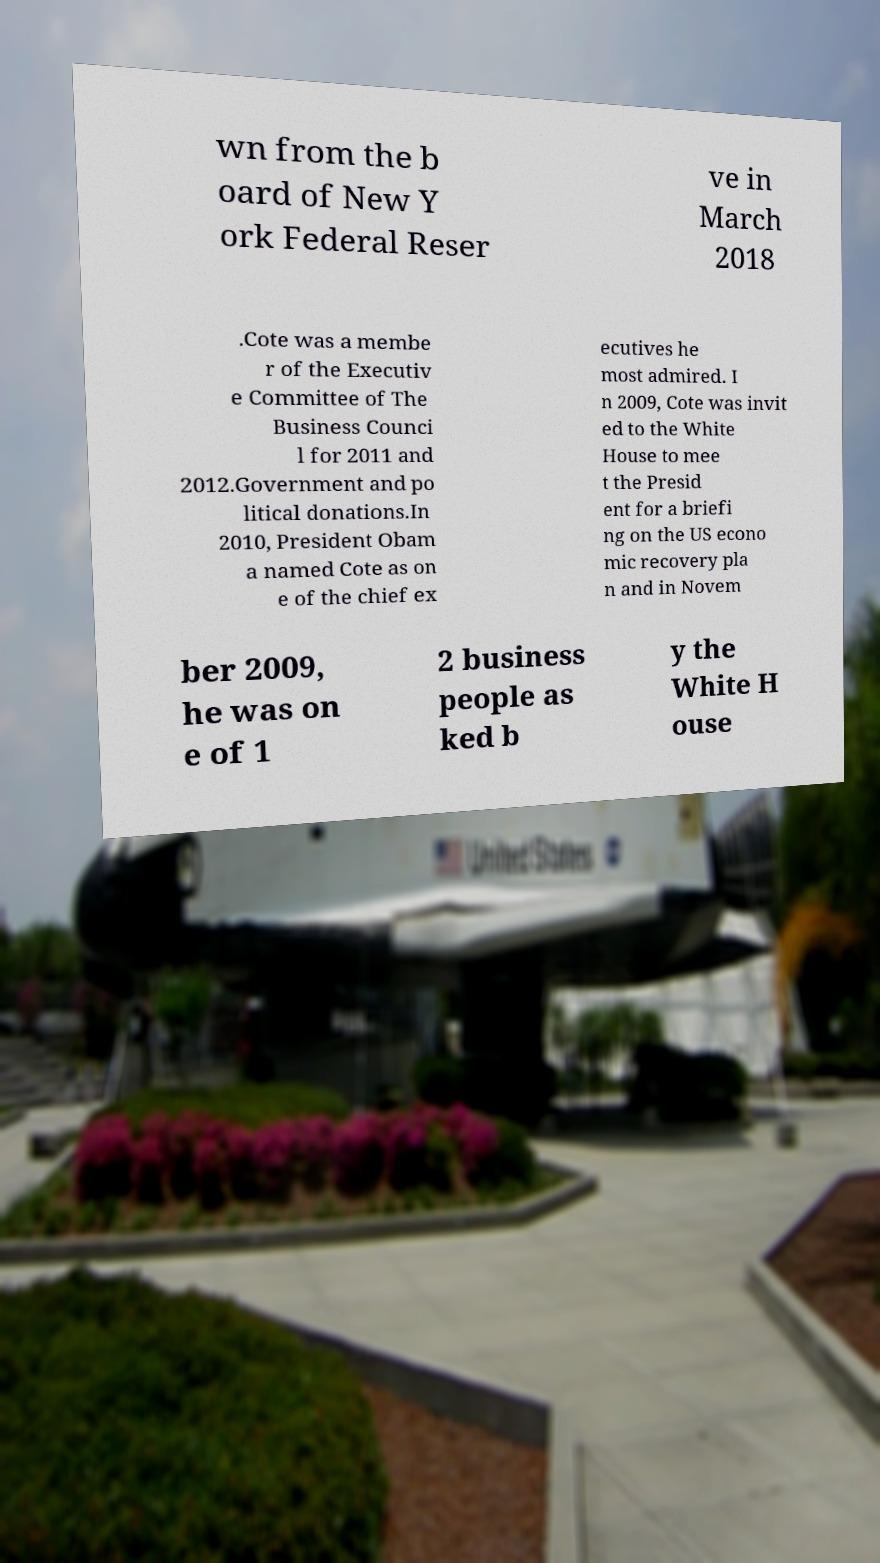I need the written content from this picture converted into text. Can you do that? wn from the b oard of New Y ork Federal Reser ve in March 2018 .Cote was a membe r of the Executiv e Committee of The Business Counci l for 2011 and 2012.Government and po litical donations.In 2010, President Obam a named Cote as on e of the chief ex ecutives he most admired. I n 2009, Cote was invit ed to the White House to mee t the Presid ent for a briefi ng on the US econo mic recovery pla n and in Novem ber 2009, he was on e of 1 2 business people as ked b y the White H ouse 